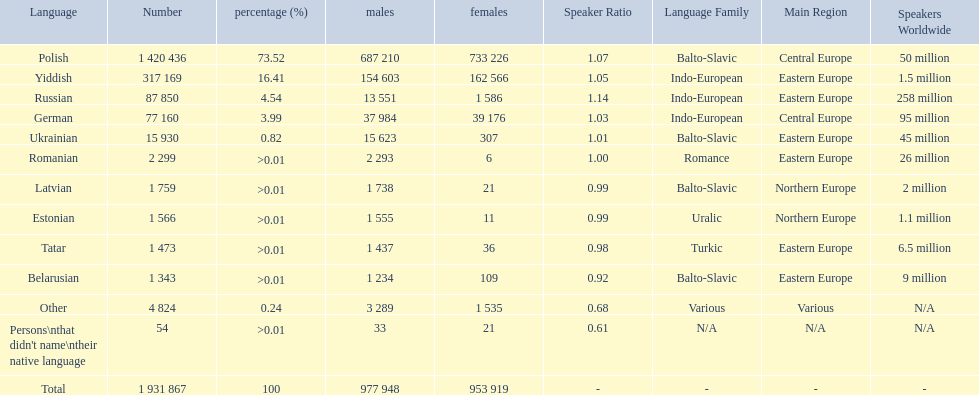What were all the languages? Polish, Yiddish, Russian, German, Ukrainian, Romanian, Latvian, Estonian, Tatar, Belarusian, Other, Persons\nthat didn't name\ntheir native language. For these, how many people spoke them? 1 420 436, 317 169, 87 850, 77 160, 15 930, 2 299, 1 759, 1 566, 1 473, 1 343, 4 824, 54. Of these, which is the largest number of speakers? 1 420 436. Which language corresponds to this number? Polish. 